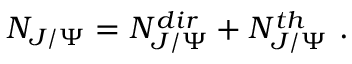<formula> <loc_0><loc_0><loc_500><loc_500>N _ { J / \Psi } = N _ { J / \Psi } ^ { d i r } + N _ { J / \Psi } ^ { t h } \ .</formula> 